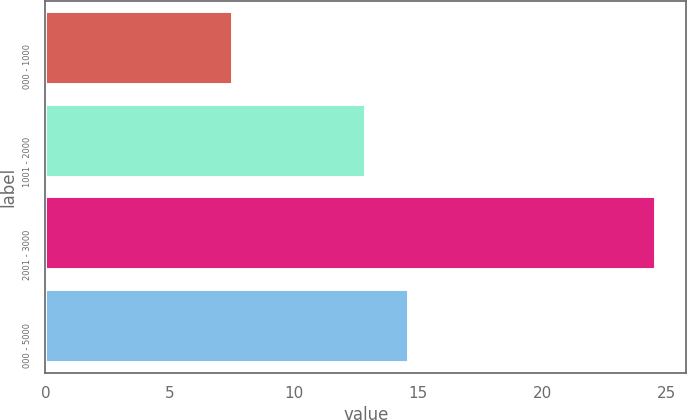Convert chart to OTSL. <chart><loc_0><loc_0><loc_500><loc_500><bar_chart><fcel>000 - 1000<fcel>1001 - 2000<fcel>2001 - 3000<fcel>000 - 5000<nl><fcel>7.55<fcel>12.93<fcel>24.58<fcel>14.63<nl></chart> 